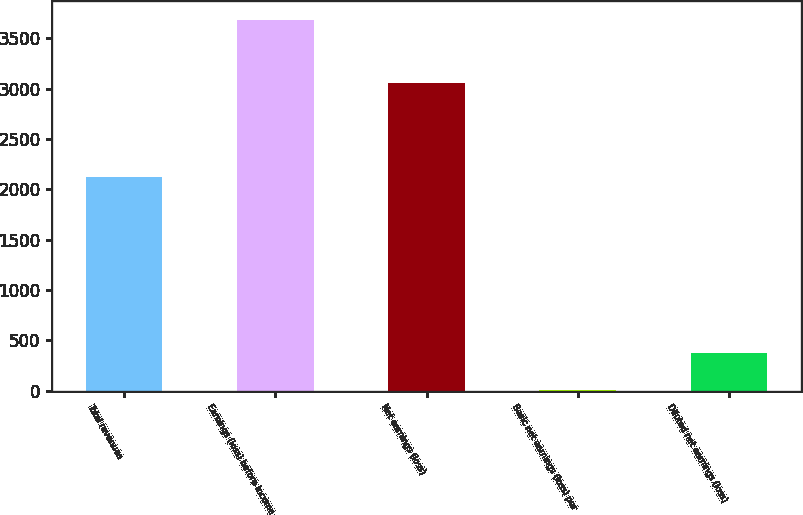Convert chart. <chart><loc_0><loc_0><loc_500><loc_500><bar_chart><fcel>Total revenues<fcel>Earnings (loss) before income<fcel>Net earnings (loss)<fcel>Basic net earnings (loss) per<fcel>Diluted net earnings (loss)<nl><fcel>2126<fcel>3685<fcel>3056<fcel>6.44<fcel>374.3<nl></chart> 